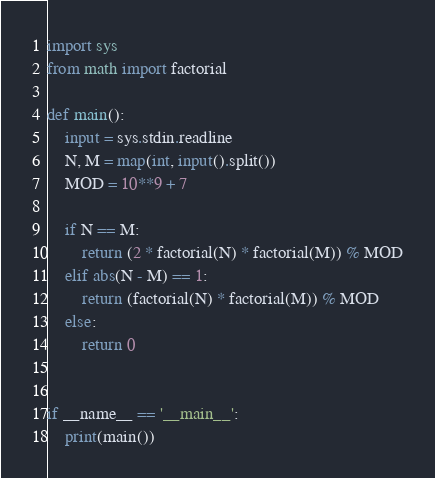Convert code to text. <code><loc_0><loc_0><loc_500><loc_500><_Python_>import sys
from math import factorial

def main():
    input = sys.stdin.readline
    N, M = map(int, input().split())
    MOD = 10**9 + 7

    if N == M:
        return (2 * factorial(N) * factorial(M)) % MOD
    elif abs(N - M) == 1:
        return (factorial(N) * factorial(M)) % MOD
    else:
        return 0


if __name__ == '__main__':
    print(main())
</code> 